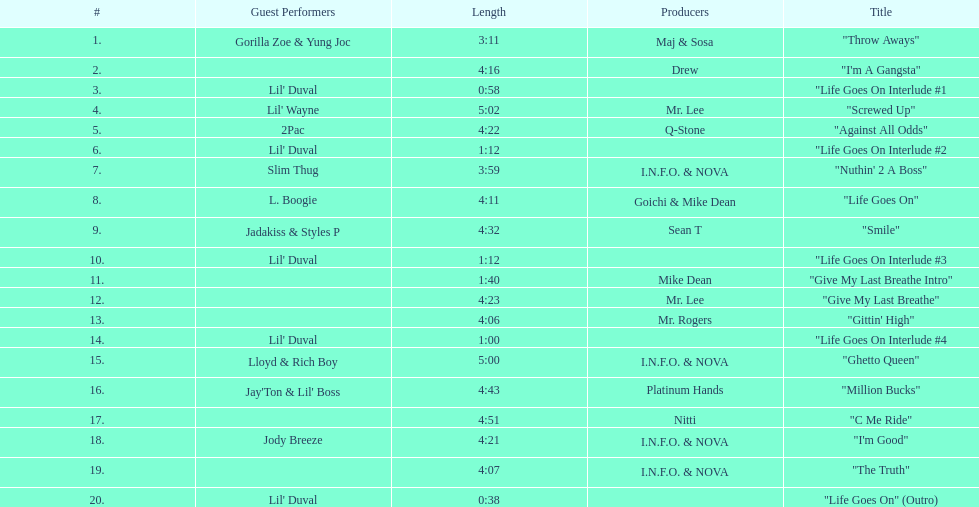What is the total number of tracks on the album? 20. I'm looking to parse the entire table for insights. Could you assist me with that? {'header': ['#', 'Guest Performers', 'Length', 'Producers', 'Title'], 'rows': [['1.', 'Gorilla Zoe & Yung Joc', '3:11', 'Maj & Sosa', '"Throw Aways"'], ['2.', '', '4:16', 'Drew', '"I\'m A Gangsta"'], ['3.', "Lil' Duval", '0:58', '', '"Life Goes On Interlude #1'], ['4.', "Lil' Wayne", '5:02', 'Mr. Lee', '"Screwed Up"'], ['5.', '2Pac', '4:22', 'Q-Stone', '"Against All Odds"'], ['6.', "Lil' Duval", '1:12', '', '"Life Goes On Interlude #2'], ['7.', 'Slim Thug', '3:59', 'I.N.F.O. & NOVA', '"Nuthin\' 2 A Boss"'], ['8.', 'L. Boogie', '4:11', 'Goichi & Mike Dean', '"Life Goes On"'], ['9.', 'Jadakiss & Styles P', '4:32', 'Sean T', '"Smile"'], ['10.', "Lil' Duval", '1:12', '', '"Life Goes On Interlude #3'], ['11.', '', '1:40', 'Mike Dean', '"Give My Last Breathe Intro"'], ['12.', '', '4:23', 'Mr. Lee', '"Give My Last Breathe"'], ['13.', '', '4:06', 'Mr. Rogers', '"Gittin\' High"'], ['14.', "Lil' Duval", '1:00', '', '"Life Goes On Interlude #4'], ['15.', 'Lloyd & Rich Boy', '5:00', 'I.N.F.O. & NOVA', '"Ghetto Queen"'], ['16.', "Jay'Ton & Lil' Boss", '4:43', 'Platinum Hands', '"Million Bucks"'], ['17.', '', '4:51', 'Nitti', '"C Me Ride"'], ['18.', 'Jody Breeze', '4:21', 'I.N.F.O. & NOVA', '"I\'m Good"'], ['19.', '', '4:07', 'I.N.F.O. & NOVA', '"The Truth"'], ['20.', "Lil' Duval", '0:38', '', '"Life Goes On" (Outro)']]} 